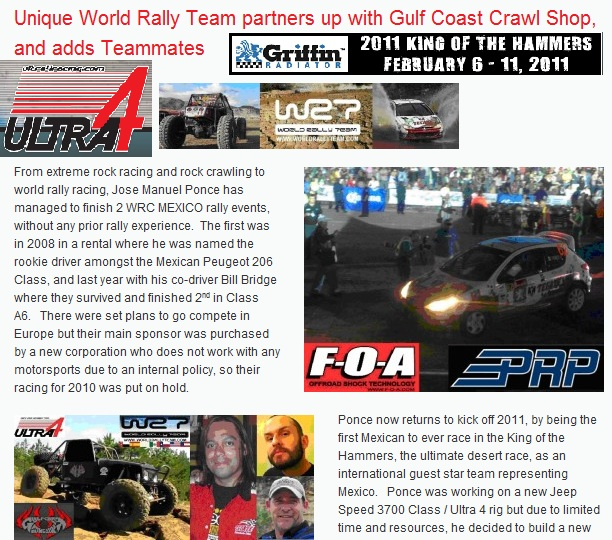What can you tell about Jose Manuel Ponce's achievements in rally racing? Jose Manuel Ponce has demonstrated impressive achievements in rally racing, especially considering he had no prior rally experience before competing. He finished the WRC Mexico rally twice: his first attempt in 2008 saw him named the rookie driver among the Mexican Peugeot 206 Class, and he managed to finish 2nd in Class A6. In subsequent years, he has continued to excel, showcasing remarkable driving skills and determination. How did Jose Manuel Ponce manage to achieve this success despite his lack of prior experience? Jose Manuel Ponce's success can be attributed to a combination of factors, including his passion for motorsports, his ability to quickly adapt to the demands of rally racing, and his strong support system, which includes his co-driver Bill Bridge. Additionally, partnerships with sponsors such as the Gulf Coast Crawl Shop, ULTRA4, and others have provided the necessary resources and support. His perseverance and determination to overcome the challenges of rally racing played a crucial role in his achievements. 